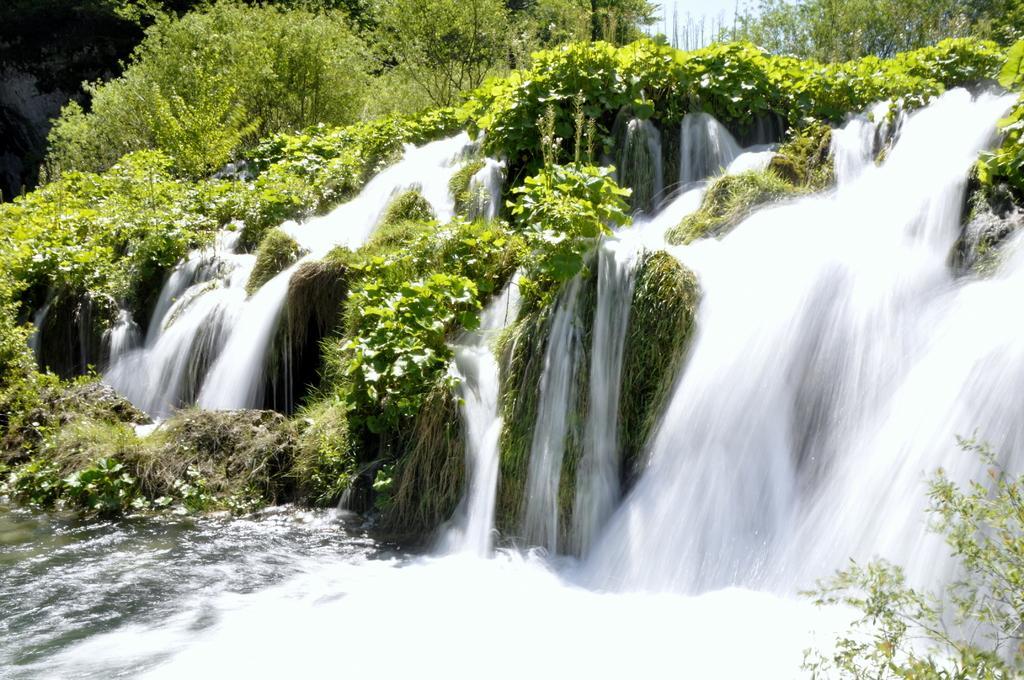Could you give a brief overview of what you see in this image? In this image we can see a waterfall and a group of trees. In the background, we can see the sky. 